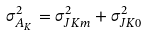<formula> <loc_0><loc_0><loc_500><loc_500>\sigma _ { A _ { K } } ^ { 2 } = \sigma _ { J K m } ^ { 2 } + \sigma _ { J K 0 } ^ { 2 }</formula> 